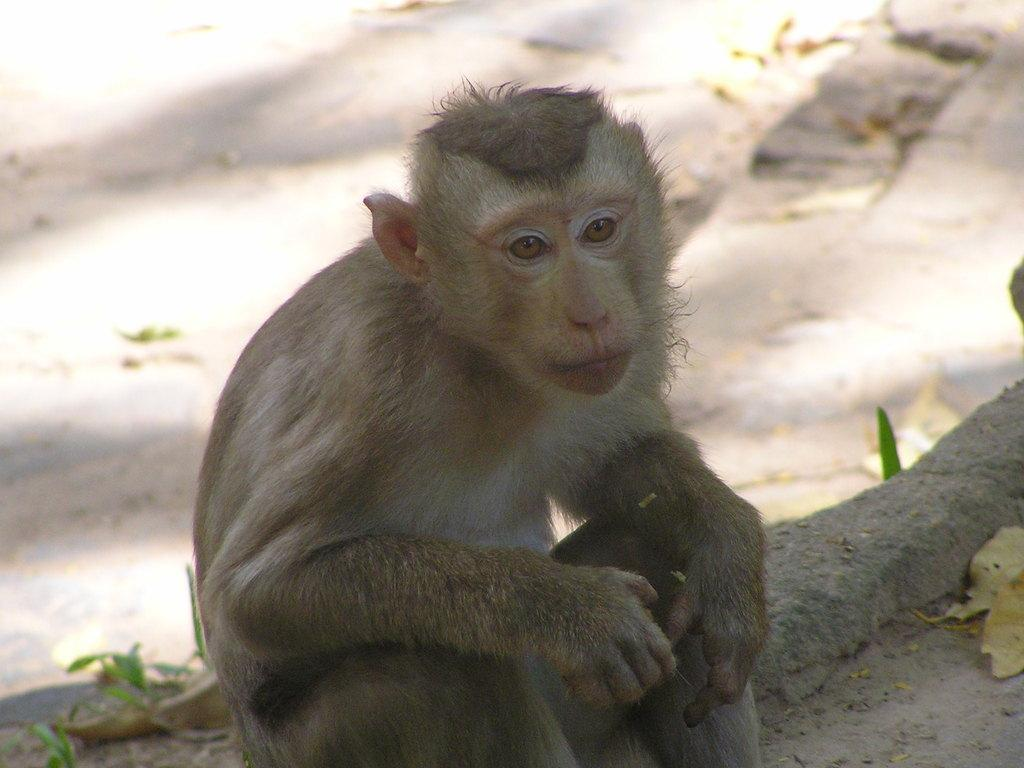What animal is present in the image? There is a monkey in the image. What is the monkey doing in the image? The monkey is sitting on the ground. What type of vegetation can be seen in the image? There are leaves visible in the image. Where is the drawer located in the image? There is no drawer present in the image. What type of worm can be seen crawling on the monkey's back in the image? There are no worms present in the image; only a monkey sitting on the ground and leaves can be seen. 